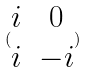<formula> <loc_0><loc_0><loc_500><loc_500>( \begin{matrix} i & 0 \\ i & - i \end{matrix} )</formula> 